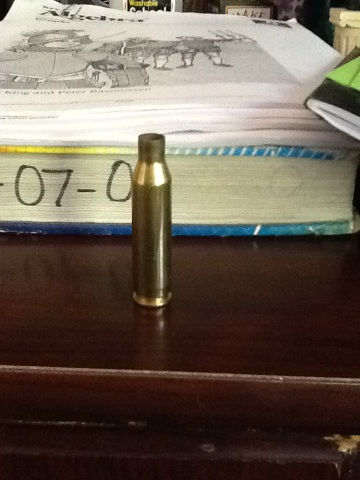What might the numbers on the books behind indicate? The numbers '07-08' on the books likely indicate the academic year (2007-2008), suggesting these books might be scholarly materials or academic planners used for reference or organization during that period. 